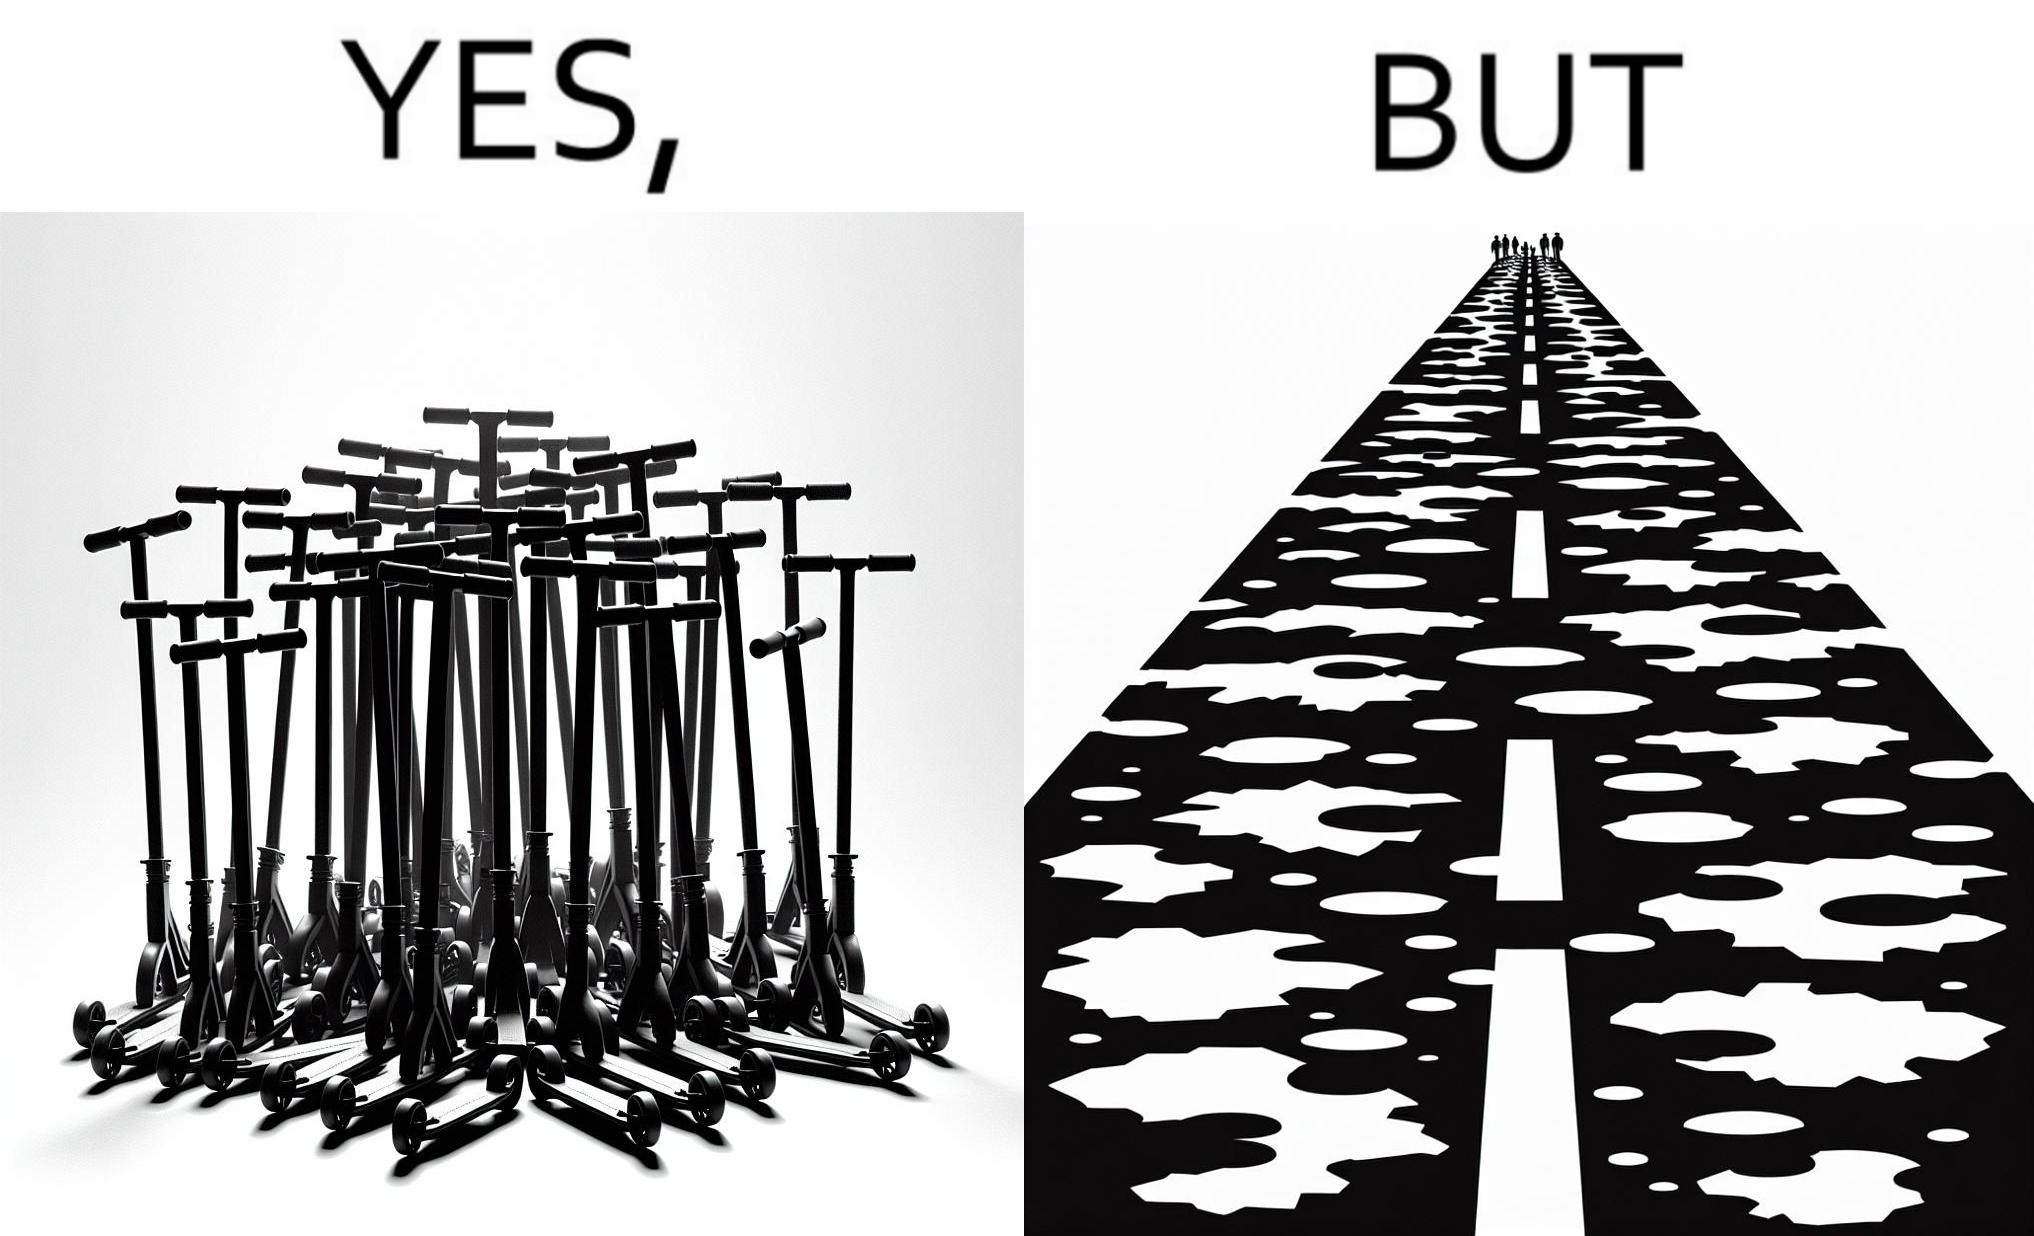Describe what you see in this image. The image is ironic, because even after when the skateboard scooters are available for someone to ride but the road has many potholes that it is not suitable to ride the scooters on such roads 